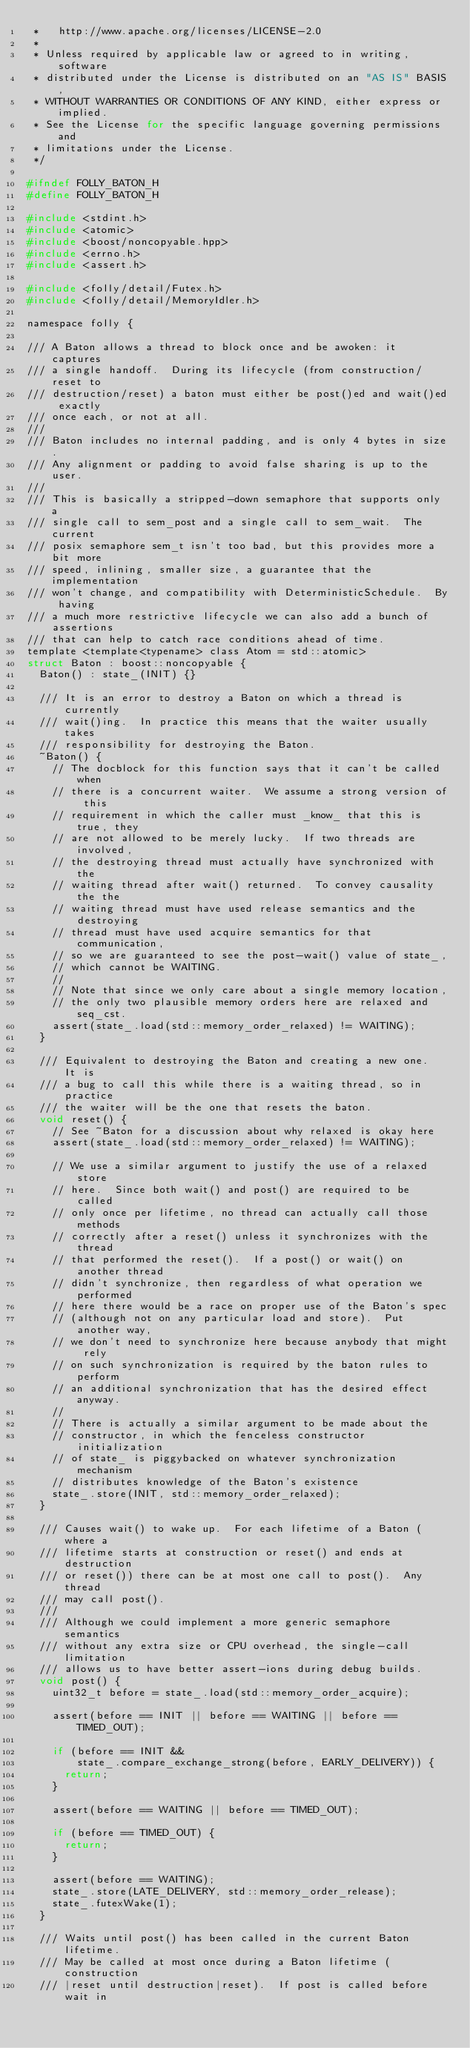Convert code to text. <code><loc_0><loc_0><loc_500><loc_500><_C_> *   http://www.apache.org/licenses/LICENSE-2.0
 *
 * Unless required by applicable law or agreed to in writing, software
 * distributed under the License is distributed on an "AS IS" BASIS,
 * WITHOUT WARRANTIES OR CONDITIONS OF ANY KIND, either express or implied.
 * See the License for the specific language governing permissions and
 * limitations under the License.
 */

#ifndef FOLLY_BATON_H
#define FOLLY_BATON_H

#include <stdint.h>
#include <atomic>
#include <boost/noncopyable.hpp>
#include <errno.h>
#include <assert.h>

#include <folly/detail/Futex.h>
#include <folly/detail/MemoryIdler.h>

namespace folly {

/// A Baton allows a thread to block once and be awoken: it captures
/// a single handoff.  During its lifecycle (from construction/reset to
/// destruction/reset) a baton must either be post()ed and wait()ed exactly
/// once each, or not at all.
///
/// Baton includes no internal padding, and is only 4 bytes in size.
/// Any alignment or padding to avoid false sharing is up to the user.
///
/// This is basically a stripped-down semaphore that supports only a
/// single call to sem_post and a single call to sem_wait.  The current
/// posix semaphore sem_t isn't too bad, but this provides more a bit more
/// speed, inlining, smaller size, a guarantee that the implementation
/// won't change, and compatibility with DeterministicSchedule.  By having
/// a much more restrictive lifecycle we can also add a bunch of assertions
/// that can help to catch race conditions ahead of time.
template <template<typename> class Atom = std::atomic>
struct Baton : boost::noncopyable {
  Baton() : state_(INIT) {}

  /// It is an error to destroy a Baton on which a thread is currently
  /// wait()ing.  In practice this means that the waiter usually takes
  /// responsibility for destroying the Baton.
  ~Baton() {
    // The docblock for this function says that it can't be called when
    // there is a concurrent waiter.  We assume a strong version of this
    // requirement in which the caller must _know_ that this is true, they
    // are not allowed to be merely lucky.  If two threads are involved,
    // the destroying thread must actually have synchronized with the
    // waiting thread after wait() returned.  To convey causality the the
    // waiting thread must have used release semantics and the destroying
    // thread must have used acquire semantics for that communication,
    // so we are guaranteed to see the post-wait() value of state_,
    // which cannot be WAITING.
    //
    // Note that since we only care about a single memory location,
    // the only two plausible memory orders here are relaxed and seq_cst.
    assert(state_.load(std::memory_order_relaxed) != WAITING);
  }

  /// Equivalent to destroying the Baton and creating a new one.  It is
  /// a bug to call this while there is a waiting thread, so in practice
  /// the waiter will be the one that resets the baton.
  void reset() {
    // See ~Baton for a discussion about why relaxed is okay here
    assert(state_.load(std::memory_order_relaxed) != WAITING);

    // We use a similar argument to justify the use of a relaxed store
    // here.  Since both wait() and post() are required to be called
    // only once per lifetime, no thread can actually call those methods
    // correctly after a reset() unless it synchronizes with the thread
    // that performed the reset().  If a post() or wait() on another thread
    // didn't synchronize, then regardless of what operation we performed
    // here there would be a race on proper use of the Baton's spec
    // (although not on any particular load and store).  Put another way,
    // we don't need to synchronize here because anybody that might rely
    // on such synchronization is required by the baton rules to perform
    // an additional synchronization that has the desired effect anyway.
    //
    // There is actually a similar argument to be made about the
    // constructor, in which the fenceless constructor initialization
    // of state_ is piggybacked on whatever synchronization mechanism
    // distributes knowledge of the Baton's existence
    state_.store(INIT, std::memory_order_relaxed);
  }

  /// Causes wait() to wake up.  For each lifetime of a Baton (where a
  /// lifetime starts at construction or reset() and ends at destruction
  /// or reset()) there can be at most one call to post().  Any thread
  /// may call post().
  ///
  /// Although we could implement a more generic semaphore semantics
  /// without any extra size or CPU overhead, the single-call limitation
  /// allows us to have better assert-ions during debug builds.
  void post() {
    uint32_t before = state_.load(std::memory_order_acquire);

    assert(before == INIT || before == WAITING || before == TIMED_OUT);

    if (before == INIT &&
        state_.compare_exchange_strong(before, EARLY_DELIVERY)) {
      return;
    }

    assert(before == WAITING || before == TIMED_OUT);

    if (before == TIMED_OUT) {
      return;
    }

    assert(before == WAITING);
    state_.store(LATE_DELIVERY, std::memory_order_release);
    state_.futexWake(1);
  }

  /// Waits until post() has been called in the current Baton lifetime.
  /// May be called at most once during a Baton lifetime (construction
  /// |reset until destruction|reset).  If post is called before wait in</code> 